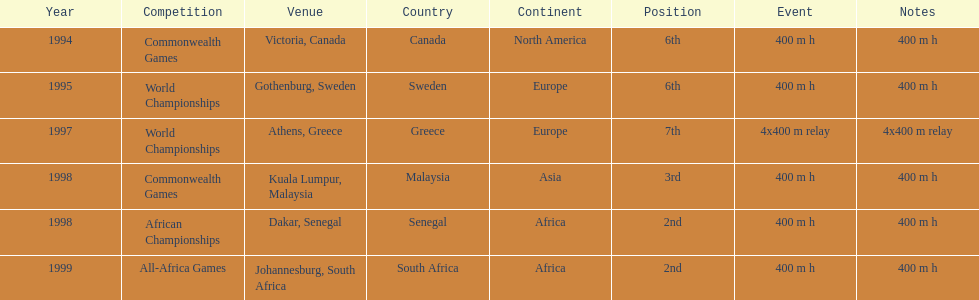Other than 1999, what year did ken harnden win second place? 1998. 